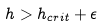<formula> <loc_0><loc_0><loc_500><loc_500>h > h _ { c r i t } + \epsilon</formula> 